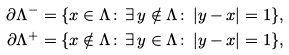<formula> <loc_0><loc_0><loc_500><loc_500>\partial \Lambda ^ { - } & = \{ x \in \Lambda \colon \, \exists \, y \notin \Lambda \colon \, | y - x | = 1 \} , \\ \partial \Lambda ^ { + } & = \{ x \notin \Lambda \colon \, \exists \, y \in \Lambda \colon \, | y - x | = 1 \} ,</formula> 